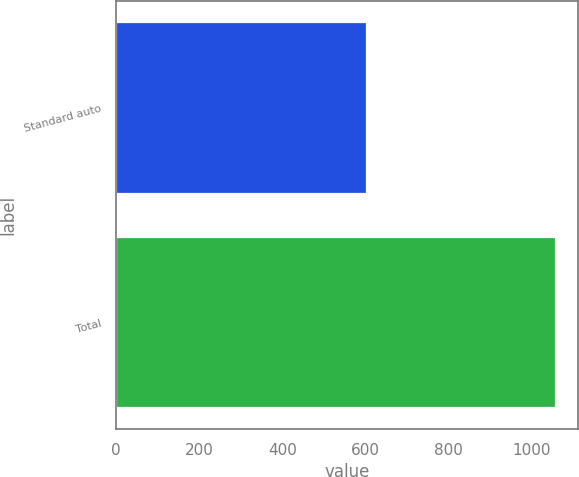Convert chart. <chart><loc_0><loc_0><loc_500><loc_500><bar_chart><fcel>Standard auto<fcel>Total<nl><fcel>604<fcel>1057<nl></chart> 